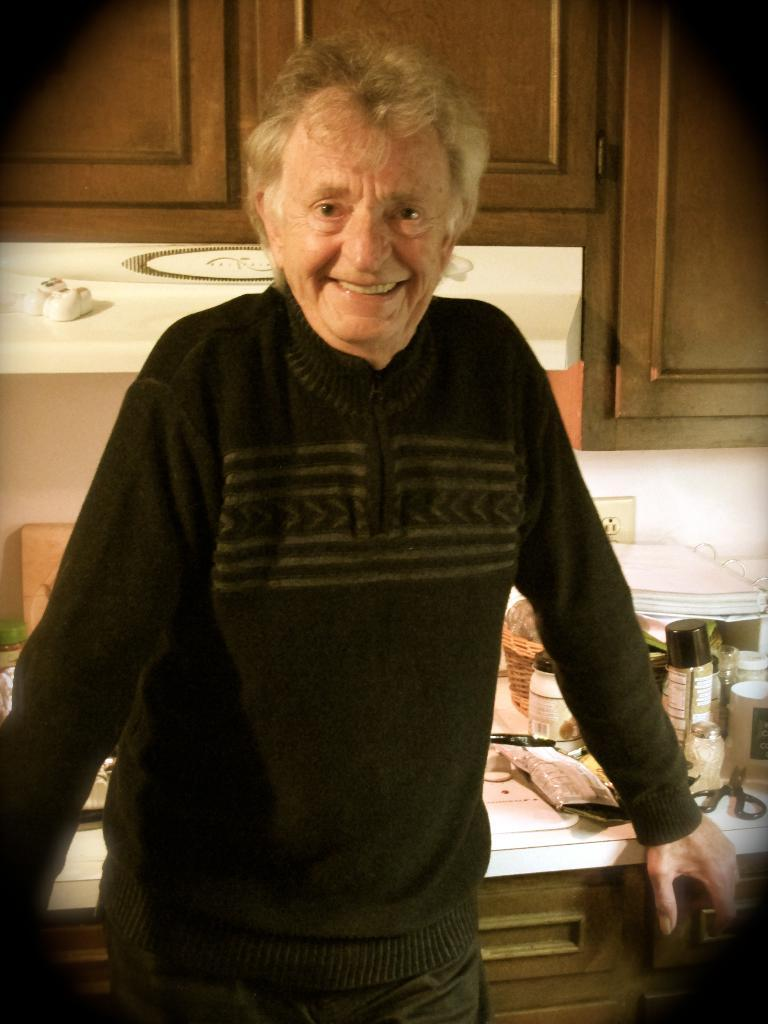What is the main subject of the image? There is a man standing in the image. What is the man wearing? The man is wearing clothes. What type of objects can be seen in the image? There are household items, a shelf, scissors, and cupboards visible in the image. Can you describe the man's expression? The man is smiling in the image. What type of writing can be seen on the jar in the image? There is no jar present in the image, so no writing can be observed. Did the man receive approval for his actions in the image? There is no indication of approval or disapproval in the image, as it only shows a man standing and smiling. 